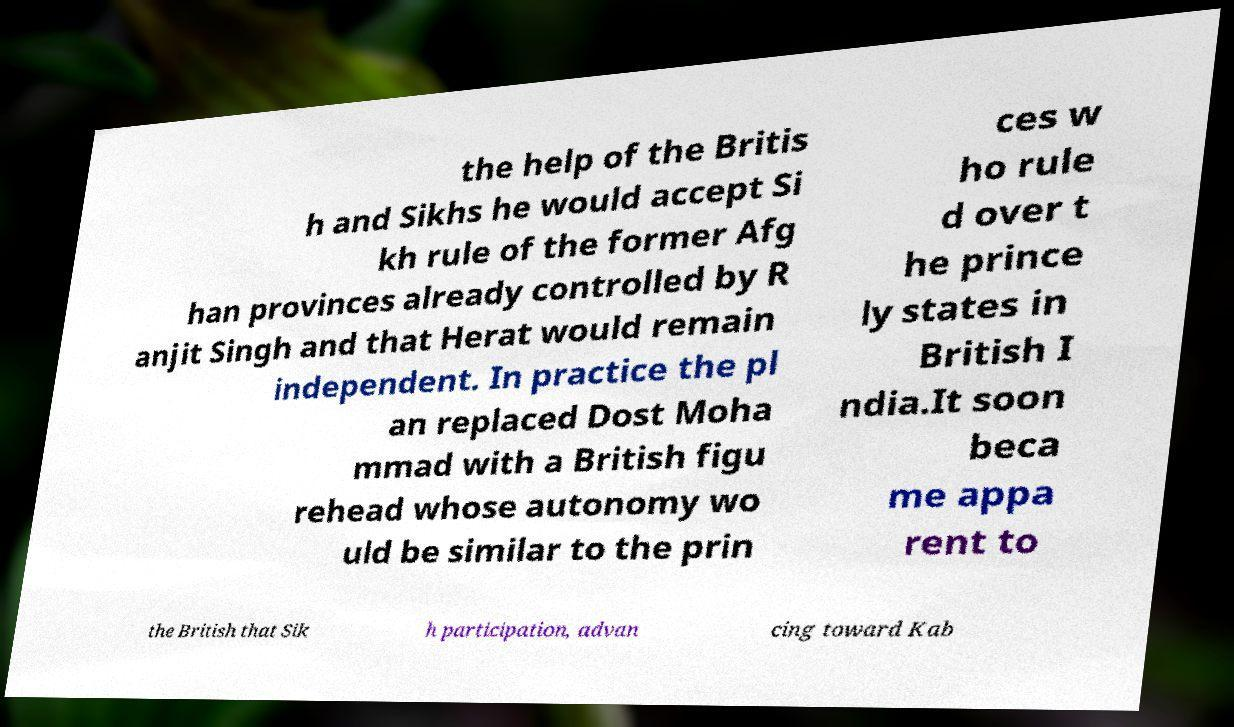Could you assist in decoding the text presented in this image and type it out clearly? the help of the Britis h and Sikhs he would accept Si kh rule of the former Afg han provinces already controlled by R anjit Singh and that Herat would remain independent. In practice the pl an replaced Dost Moha mmad with a British figu rehead whose autonomy wo uld be similar to the prin ces w ho rule d over t he prince ly states in British I ndia.It soon beca me appa rent to the British that Sik h participation, advan cing toward Kab 